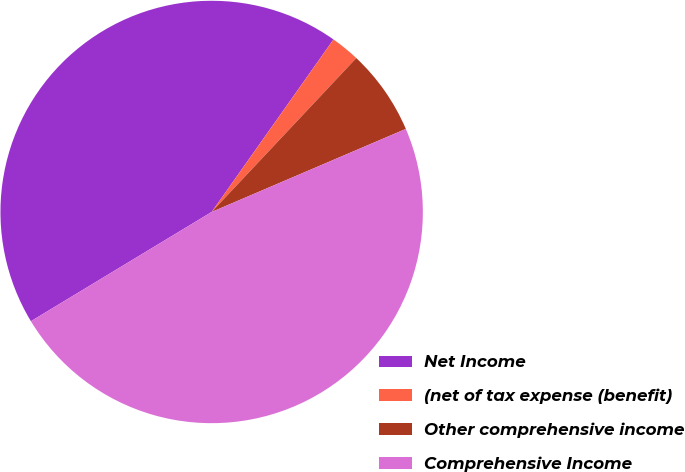Convert chart to OTSL. <chart><loc_0><loc_0><loc_500><loc_500><pie_chart><fcel>Net Income<fcel>(net of tax expense (benefit)<fcel>Other comprehensive income<fcel>Comprehensive Income<nl><fcel>43.44%<fcel>2.22%<fcel>6.56%<fcel>47.78%<nl></chart> 